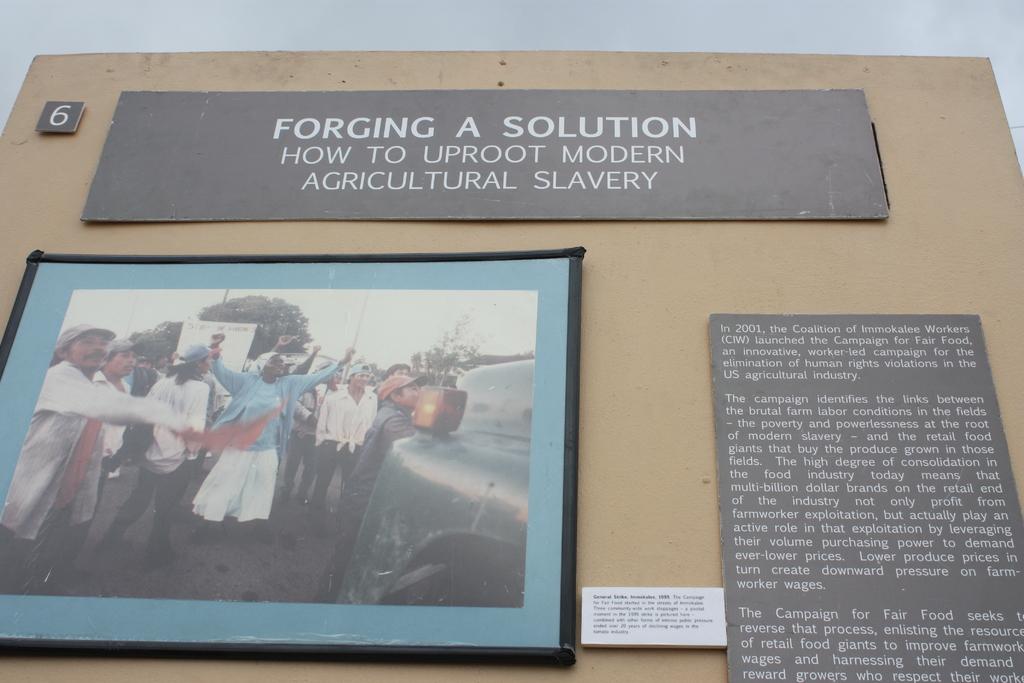What year was the campaign for fair food launched?
Make the answer very short. 2001. What does the poster want to do to modern agricultural slavery?
Offer a very short reply. Uproot. 